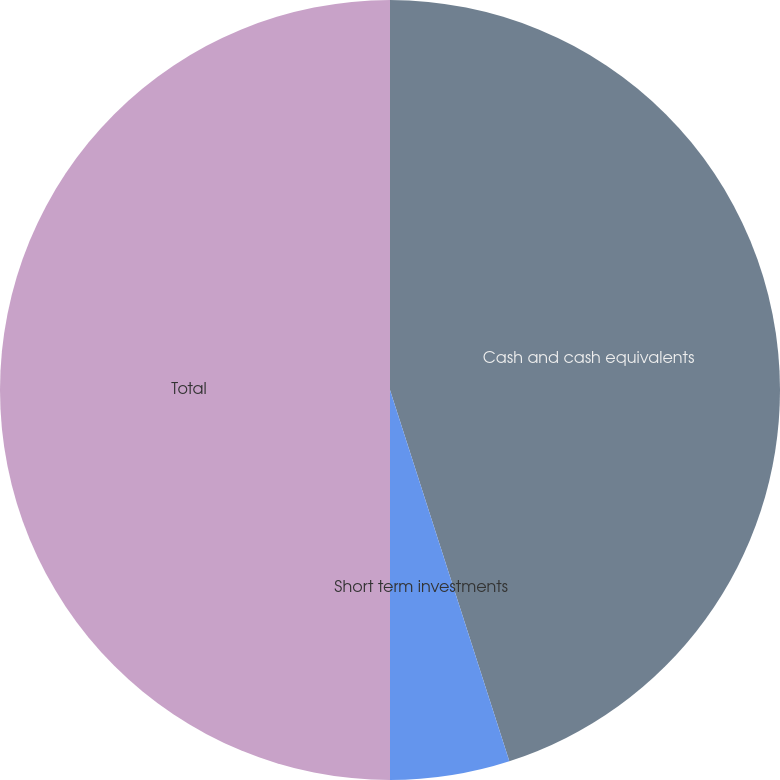Convert chart. <chart><loc_0><loc_0><loc_500><loc_500><pie_chart><fcel>Cash and cash equivalents<fcel>Short term investments<fcel>Total<nl><fcel>45.05%<fcel>4.95%<fcel>50.0%<nl></chart> 